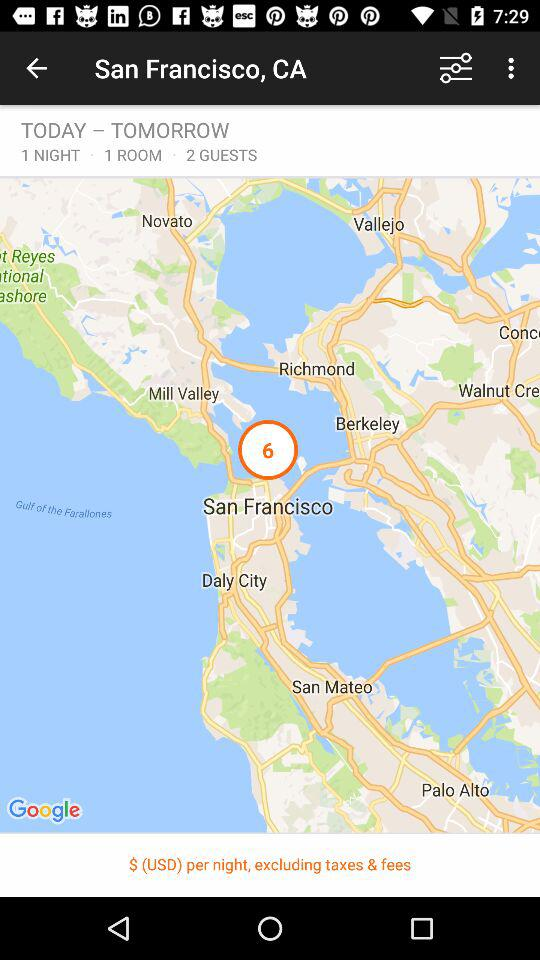How many rooms were booked? The number of rooms booked was 1. 